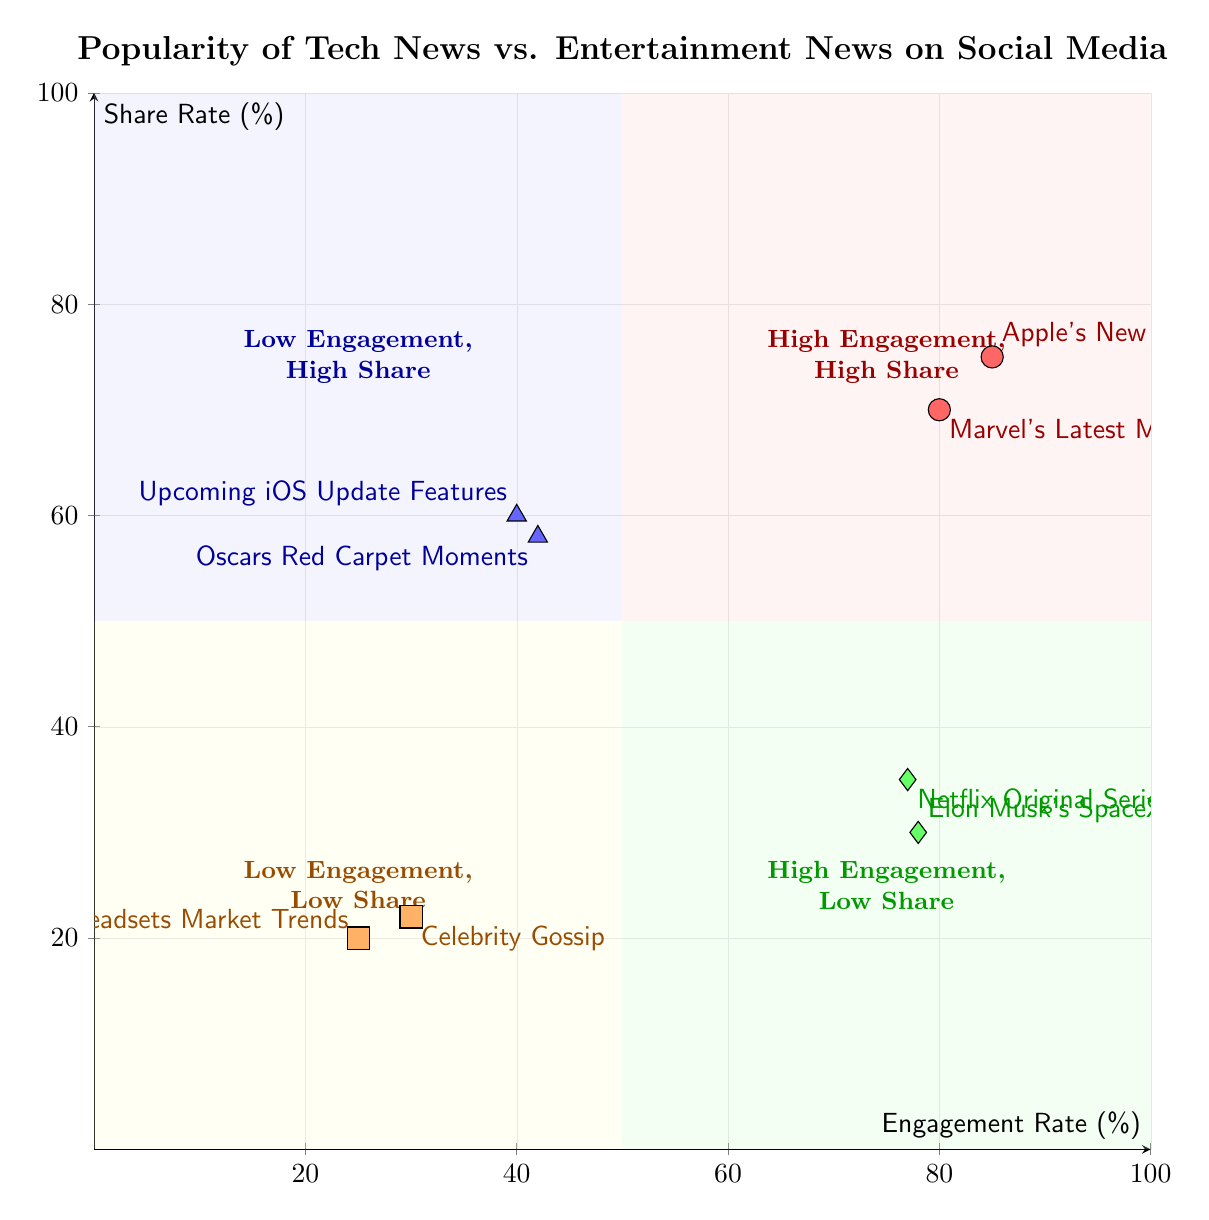What are the engagement rates of Apple's New Product Launch and Marvel's Latest Movie Trailer? The engagement rates of Apple's New Product Launch is 85% and Marvel's Latest Movie Trailer is 80%. Both values can be found on the x-axis of the Quadrant chart, where each point in the High Engagement, High Share quadrant represents these specific titles.
Answer: 85%, 80% Which news type has the lowest engagement rate? The lowest engagement rate is found in the Low Engagement, Low Share quadrant, where the data points represent "VR Headsets Market Trends" (25%) and "Celebrity Gossip" (30%). Thus, "VR Headsets Market Trends" is the title with the absolute lowest engagement rate.
Answer: VR Headsets Market Trends How many examples are in the High Engagement, Low Share quadrant? In the High Engagement, Low Share quadrant, there are two examples listed: "Elon Musk's SpaceX Updates" and "Netflix Original Series Review". The count can be determined by counting the examples provided within that specific quadrant.
Answer: 2 What is the share rate of the Oscars Red Carpet Moments? The share rate for "Oscars Red Carpet Moments" is located within the Low Engagement, High Share quadrant at 58%. This is represented on the y-axis where the data point for this title is plotted.
Answer: 58% Which quadrant contains news with both low engagement and low share rates? The quadrant that contains both low engagement and low share rates is the Low Engagement, Low Share quadrant. Here, both examples "VR Headsets Market Trends" and "Celebrity Gossip" fall into this category according to their plotted data points.
Answer: Low Engagement, Low Share What example has a higher share rate: Upcoming iOS Update Features or Celebrity Gossip? "Upcoming iOS Update Features" has a share rate of 60%, while "Celebrity Gossip" has a share rate of 22%. By directly comparing the two values in the Low Engagement, High Share quadrant, it is clear which title has the higher share rate.
Answer: Upcoming iOS Update Features What are the titles in the High Engagement, High Share quadrant? The High Engagement, High Share quadrant contains two titles: "Apple's New Product Launch" and "Marvel's Latest Movie Trailer". These titles are specifically listed next to their respective data points in that quadrant.
Answer: Apple's New Product Launch, Marvel's Latest Movie Trailer 